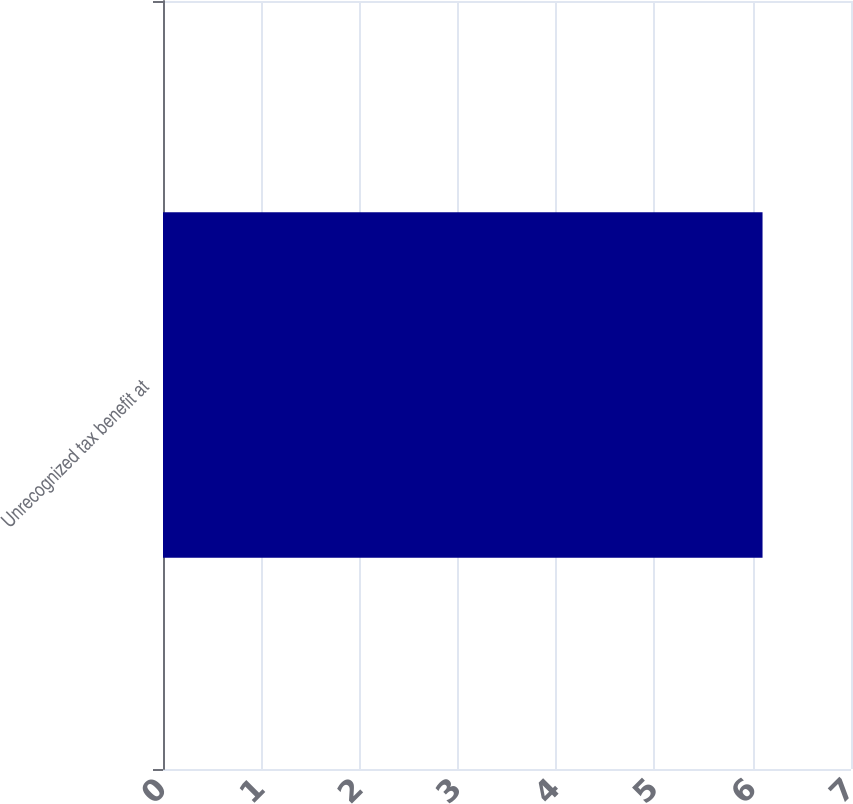<chart> <loc_0><loc_0><loc_500><loc_500><bar_chart><fcel>Unrecognized tax benefit at<nl><fcel>6.1<nl></chart> 